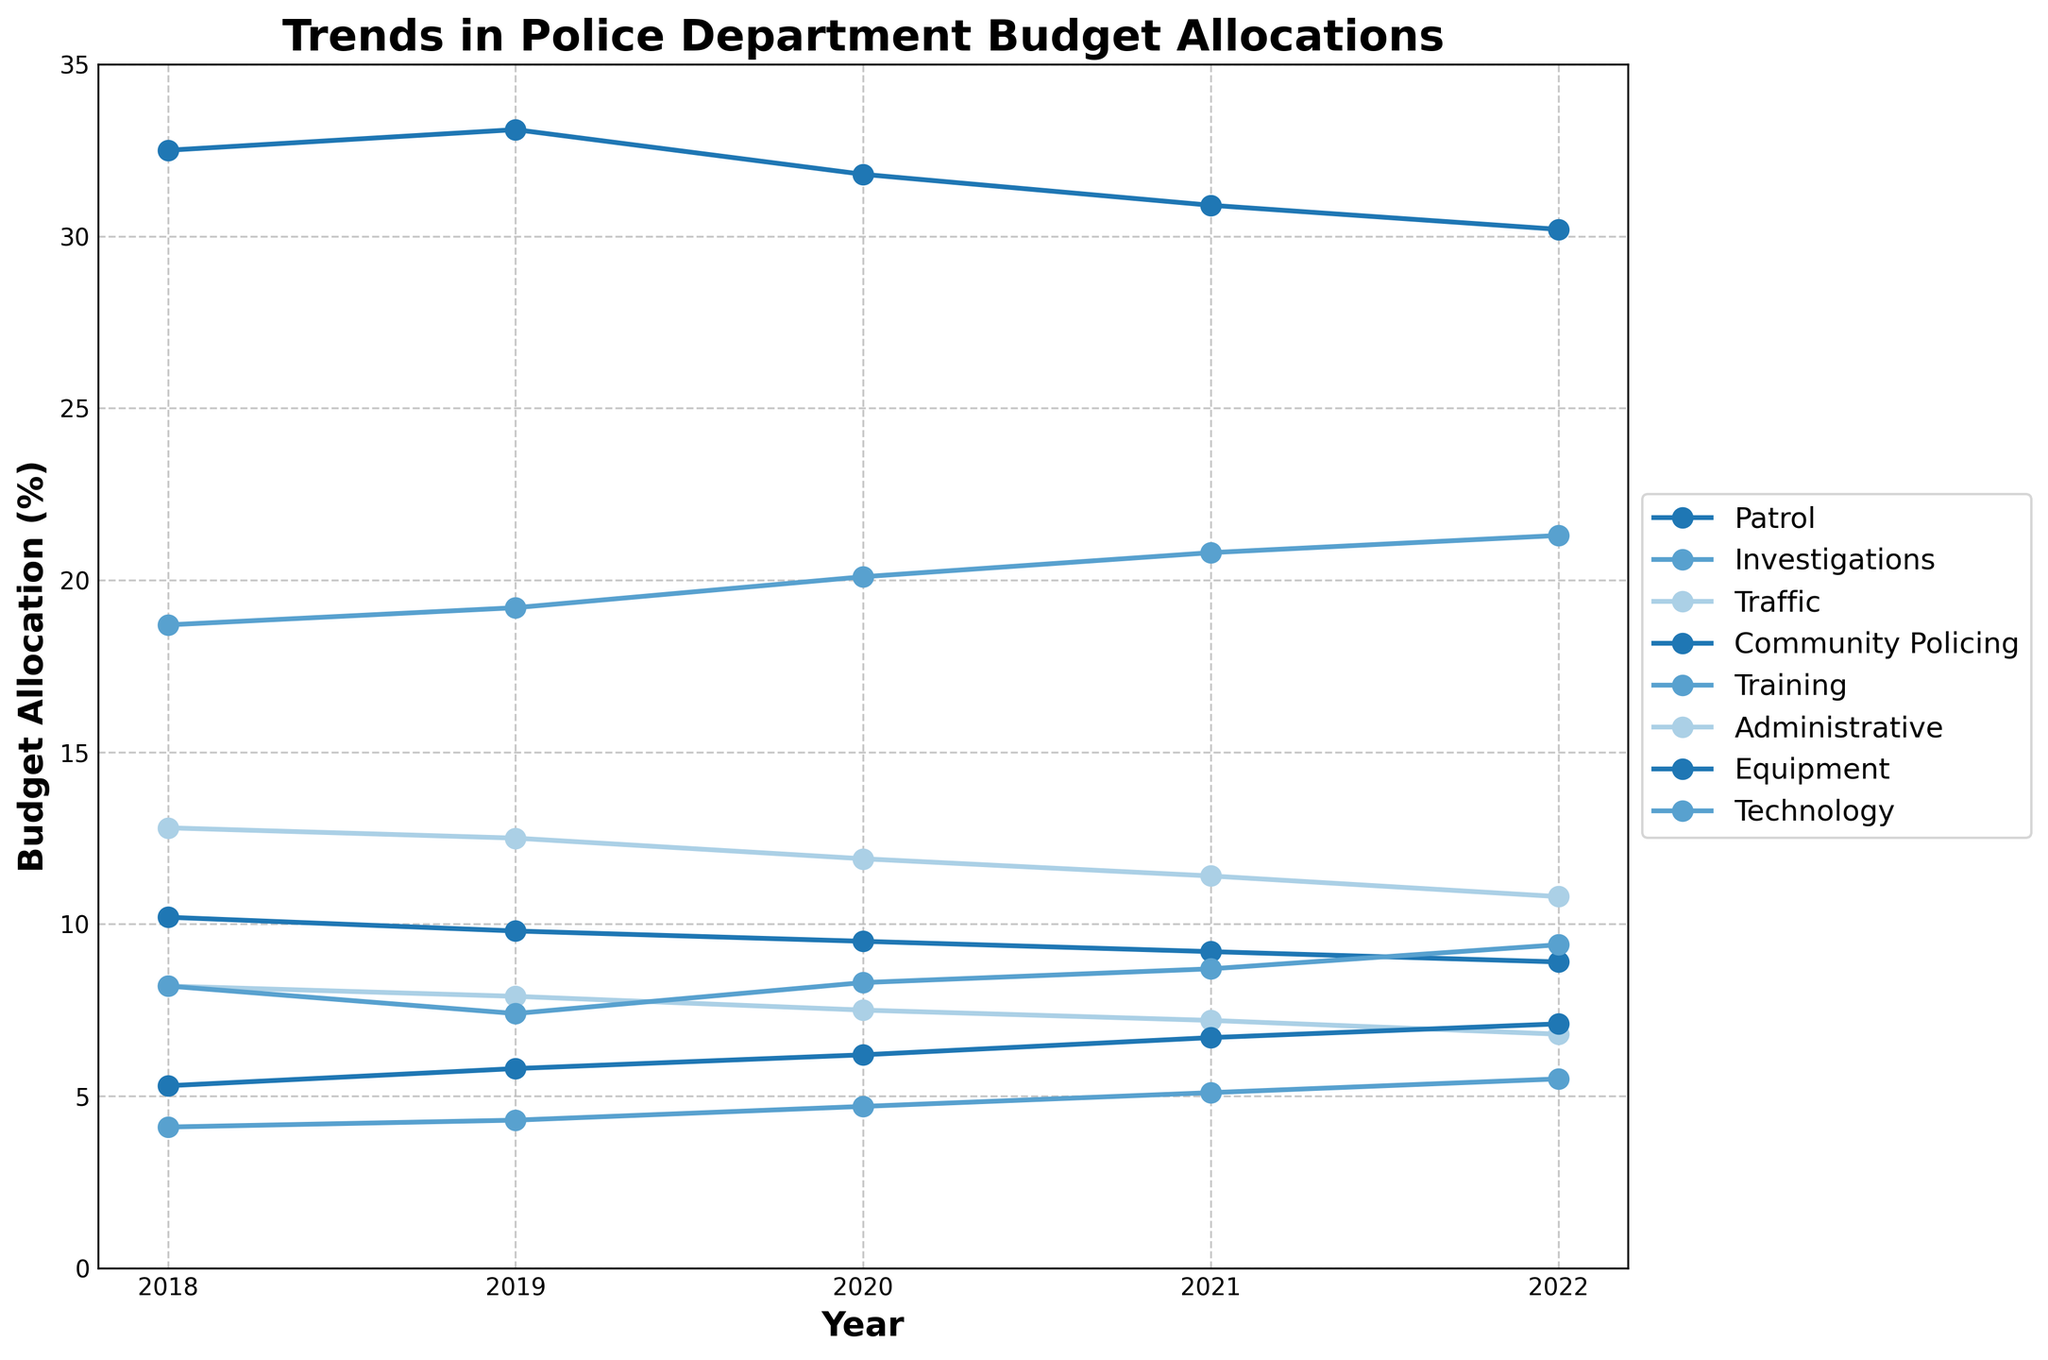Which unit had the highest budget allocation in 2018? By looking at the line chart, identify which line has the highest point in the year 2018. The line for Patrol has the highest value.
Answer: Patrol How did the budget allocation for Community Policing change from 2018 to 2022? Compare the position of the Community Policing line at 2018 and 2022. It increases from 5.3% in 2018 to 7.1% in 2022.
Answer: It increased Which unit showed a decreasing trend in its budget allocation over the 5 years? Observe the slope of each line. The lines for Traffic, Administrative, and Equipment all show a decreasing trend.
Answer: Traffic, Administrative, Equipment In which year did Technology surpass Administrative in budget allocation? Compare the positions of the Technology and Administrative lines for each year to find when Technology becomes higher. This happens in 2021.
Answer: 2021 What was the average budget allocation for Training over the 5 years? Add up the Training values for each year and divide by 5: (4.1 + 4.3 + 4.7 + 5.1 + 5.5)/5 = 23.7/5 = 4.74.
Answer: 4.74 Which unit had the smallest budget allocation in 2020? Identify the lowest point in 2020 and find the corresponding unit. Traffic has the smallest allocation with 7.5%.
Answer: Traffic Is the trend for Investigations budget allocation increasing, decreasing, or stable over 5 years? Observe the trend of the Investigations line from 2018 to 2022. It shows a consistent increase.
Answer: Increasing Which two units had a budget allocation crossing point, and in what year did this occur? Look for intersections in the lines. The lines for Equipment and Technology intersect in 2021.
Answer: Equipment and Technology, 2021 By how much did the budget allocation for Patrol change from 2018 to 2022? Calculate the difference: 30.2% (2022) - 32.5% (2018) = -2.3%.
Answer: -2.3% Comparing the units of Patrol, Investigations, and Traffic, which one had the sharpest decrease in budget allocation and by how much? Calculate the decrease for each unit: 
- Patrol: 32.5% (2018) to 30.2% (2022) = -2.3%
- Investigations: 18.7% (2018) to 21.3% (2022) = +2.6% 
- Traffic: 8.2% (2018) to 6.8% (2022) = -1.4% 
The sharpest decrease is in Patrol by 2.3%.
Answer: Patrol, -2.3% 